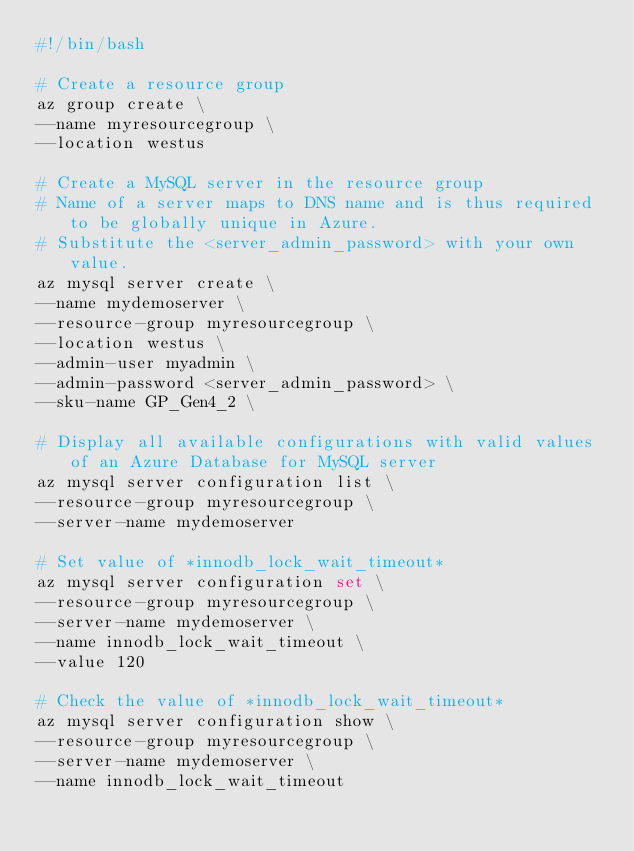<code> <loc_0><loc_0><loc_500><loc_500><_Bash_>#!/bin/bash

# Create a resource group
az group create \
--name myresourcegroup \
--location westus

# Create a MySQL server in the resource group
# Name of a server maps to DNS name and is thus required to be globally unique in Azure.
# Substitute the <server_admin_password> with your own value.
az mysql server create \
--name mydemoserver \
--resource-group myresourcegroup \
--location westus \
--admin-user myadmin \
--admin-password <server_admin_password> \
--sku-name GP_Gen4_2 \

# Display all available configurations with valid values of an Azure Database for MySQL server
az mysql server configuration list \
--resource-group myresourcegroup \
--server-name mydemoserver

# Set value of *innodb_lock_wait_timeout*
az mysql server configuration set \
--resource-group myresourcegroup \
--server-name mydemoserver \
--name innodb_lock_wait_timeout \
--value 120

# Check the value of *innodb_lock_wait_timeout*
az mysql server configuration show \
--resource-group myresourcegroup \
--server-name mydemoserver \
--name innodb_lock_wait_timeout</code> 